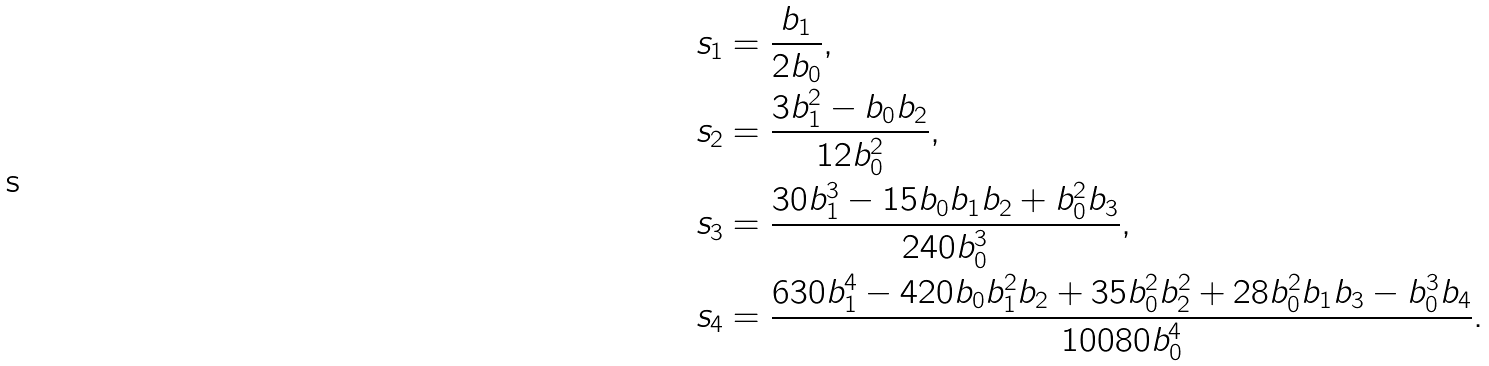Convert formula to latex. <formula><loc_0><loc_0><loc_500><loc_500>s _ { 1 } & = \frac { b _ { 1 } } { 2 b _ { 0 } } , \\ s _ { 2 } & = \frac { 3 b _ { 1 } ^ { 2 } - b _ { 0 } b _ { 2 } } { 1 2 b _ { 0 } ^ { 2 } } , \\ s _ { 3 } & = \frac { 3 0 b _ { 1 } ^ { 3 } - 1 5 b _ { 0 } b _ { 1 } b _ { 2 } + b _ { 0 } ^ { 2 } b _ { 3 } } { 2 4 0 b _ { 0 } ^ { 3 } } , \\ s _ { 4 } & = \frac { 6 3 0 b _ { 1 } ^ { 4 } - 4 2 0 b _ { 0 } b _ { 1 } ^ { 2 } b _ { 2 } + 3 5 b _ { 0 } ^ { 2 } b _ { 2 } ^ { 2 } + 2 8 b _ { 0 } ^ { 2 } b _ { 1 } b _ { 3 } - b _ { 0 } ^ { 3 } b _ { 4 } } { 1 0 0 8 0 b _ { 0 } ^ { 4 } } .</formula> 